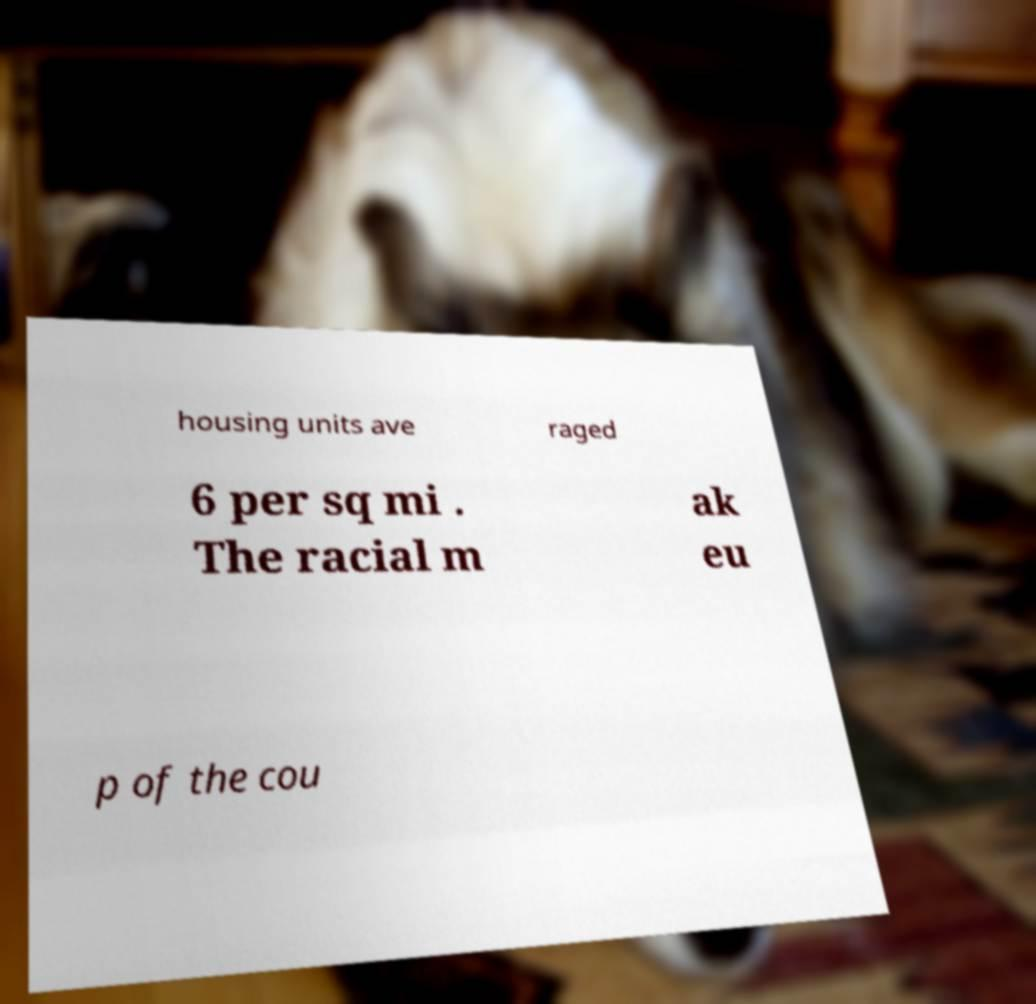There's text embedded in this image that I need extracted. Can you transcribe it verbatim? housing units ave raged 6 per sq mi . The racial m ak eu p of the cou 